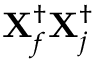Convert formula to latex. <formula><loc_0><loc_0><loc_500><loc_500>X _ { f } ^ { \dagger } X _ { j } ^ { \dagger }</formula> 